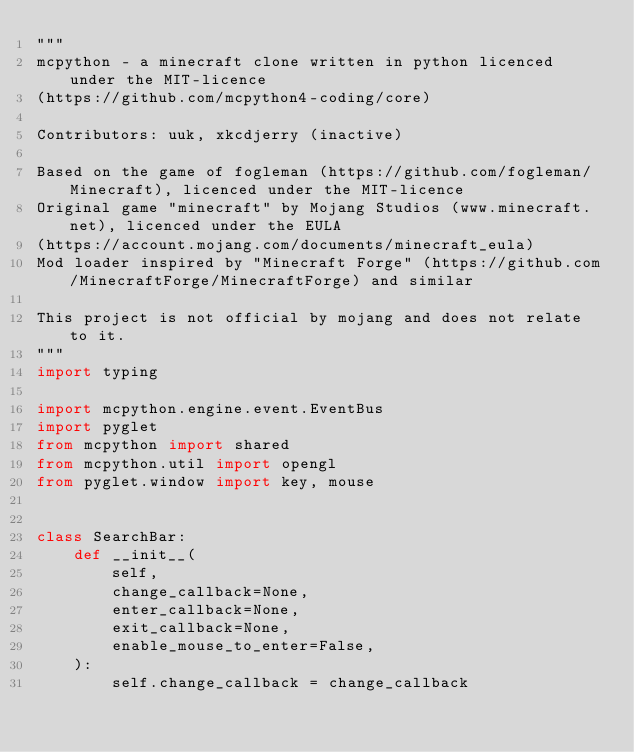<code> <loc_0><loc_0><loc_500><loc_500><_Python_>"""
mcpython - a minecraft clone written in python licenced under the MIT-licence 
(https://github.com/mcpython4-coding/core)

Contributors: uuk, xkcdjerry (inactive)

Based on the game of fogleman (https://github.com/fogleman/Minecraft), licenced under the MIT-licence
Original game "minecraft" by Mojang Studios (www.minecraft.net), licenced under the EULA
(https://account.mojang.com/documents/minecraft_eula)
Mod loader inspired by "Minecraft Forge" (https://github.com/MinecraftForge/MinecraftForge) and similar

This project is not official by mojang and does not relate to it.
"""
import typing

import mcpython.engine.event.EventBus
import pyglet
from mcpython import shared
from mcpython.util import opengl
from pyglet.window import key, mouse


class SearchBar:
    def __init__(
        self,
        change_callback=None,
        enter_callback=None,
        exit_callback=None,
        enable_mouse_to_enter=False,
    ):
        self.change_callback = change_callback</code> 